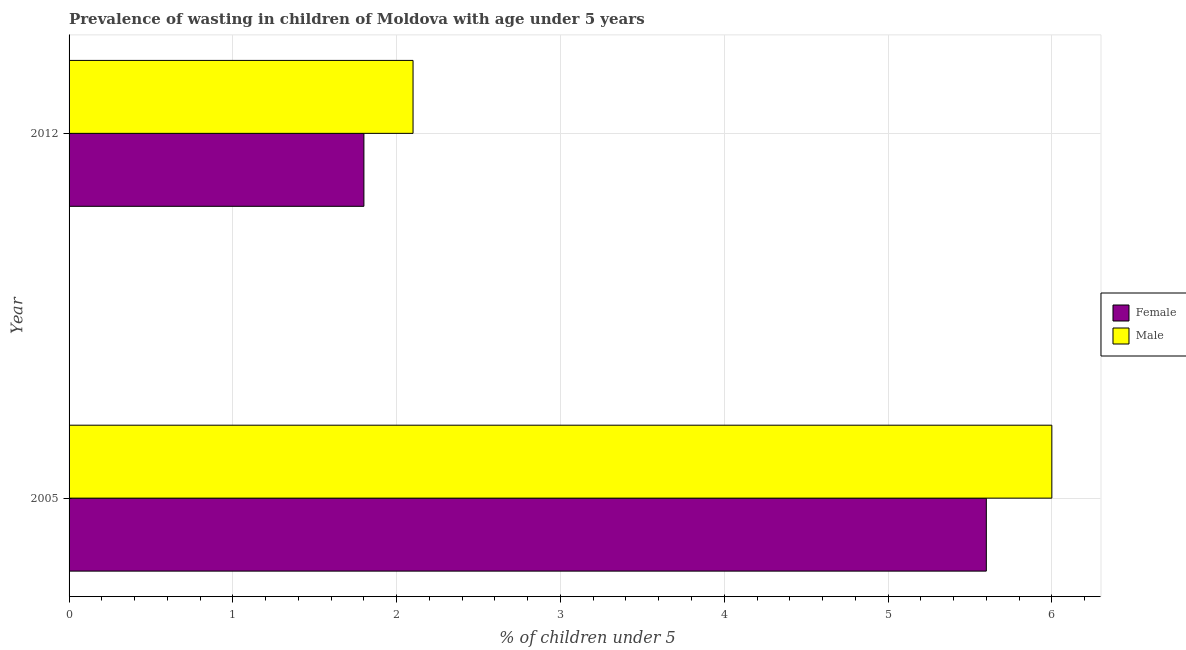How many different coloured bars are there?
Your answer should be compact. 2. How many groups of bars are there?
Keep it short and to the point. 2. How many bars are there on the 2nd tick from the bottom?
Your response must be concise. 2. What is the label of the 2nd group of bars from the top?
Keep it short and to the point. 2005. What is the percentage of undernourished female children in 2005?
Keep it short and to the point. 5.6. Across all years, what is the maximum percentage of undernourished male children?
Keep it short and to the point. 6. Across all years, what is the minimum percentage of undernourished male children?
Give a very brief answer. 2.1. What is the total percentage of undernourished female children in the graph?
Ensure brevity in your answer.  7.4. What is the difference between the percentage of undernourished female children in 2005 and the percentage of undernourished male children in 2012?
Make the answer very short. 3.5. What is the average percentage of undernourished female children per year?
Your answer should be very brief. 3.7. In the year 2012, what is the difference between the percentage of undernourished male children and percentage of undernourished female children?
Your answer should be very brief. 0.3. In how many years, is the percentage of undernourished female children greater than 4.8 %?
Your response must be concise. 1. What is the ratio of the percentage of undernourished male children in 2005 to that in 2012?
Keep it short and to the point. 2.86. Is the percentage of undernourished male children in 2005 less than that in 2012?
Offer a very short reply. No. Is the difference between the percentage of undernourished male children in 2005 and 2012 greater than the difference between the percentage of undernourished female children in 2005 and 2012?
Provide a succinct answer. Yes. In how many years, is the percentage of undernourished female children greater than the average percentage of undernourished female children taken over all years?
Offer a terse response. 1. What does the 2nd bar from the top in 2012 represents?
Keep it short and to the point. Female. Are all the bars in the graph horizontal?
Ensure brevity in your answer.  Yes. Are the values on the major ticks of X-axis written in scientific E-notation?
Make the answer very short. No. Does the graph contain any zero values?
Offer a very short reply. No. Where does the legend appear in the graph?
Offer a terse response. Center right. How are the legend labels stacked?
Offer a very short reply. Vertical. What is the title of the graph?
Make the answer very short. Prevalence of wasting in children of Moldova with age under 5 years. What is the label or title of the X-axis?
Make the answer very short.  % of children under 5. What is the label or title of the Y-axis?
Provide a succinct answer. Year. What is the  % of children under 5 in Female in 2005?
Your answer should be very brief. 5.6. What is the  % of children under 5 in Male in 2005?
Offer a terse response. 6. What is the  % of children under 5 of Female in 2012?
Keep it short and to the point. 1.8. What is the  % of children under 5 in Male in 2012?
Provide a succinct answer. 2.1. Across all years, what is the maximum  % of children under 5 in Female?
Your answer should be very brief. 5.6. Across all years, what is the maximum  % of children under 5 in Male?
Offer a very short reply. 6. Across all years, what is the minimum  % of children under 5 in Female?
Offer a terse response. 1.8. Across all years, what is the minimum  % of children under 5 in Male?
Keep it short and to the point. 2.1. What is the average  % of children under 5 in Female per year?
Provide a short and direct response. 3.7. What is the average  % of children under 5 in Male per year?
Your response must be concise. 4.05. What is the ratio of the  % of children under 5 in Female in 2005 to that in 2012?
Give a very brief answer. 3.11. What is the ratio of the  % of children under 5 of Male in 2005 to that in 2012?
Your response must be concise. 2.86. What is the difference between the highest and the second highest  % of children under 5 of Female?
Your answer should be very brief. 3.8. What is the difference between the highest and the second highest  % of children under 5 in Male?
Ensure brevity in your answer.  3.9. What is the difference between the highest and the lowest  % of children under 5 in Female?
Your answer should be very brief. 3.8. What is the difference between the highest and the lowest  % of children under 5 of Male?
Ensure brevity in your answer.  3.9. 